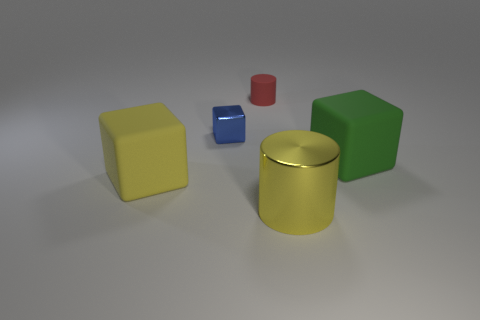How big is the cylinder that is behind the shiny block?
Offer a very short reply. Small. What size is the other object that is the same material as the blue thing?
Make the answer very short. Large. What number of matte things are the same color as the large metal cylinder?
Make the answer very short. 1. Is there a small red cylinder?
Your answer should be very brief. Yes. There is a big green rubber object; is it the same shape as the big yellow thing on the left side of the red cylinder?
Ensure brevity in your answer.  Yes. There is a small thing that is behind the metallic thing behind the big matte cube that is on the right side of the small rubber thing; what is its color?
Give a very brief answer. Red. Are there any shiny things left of the green cube?
Your response must be concise. Yes. Are there any big things made of the same material as the tiny cube?
Keep it short and to the point. Yes. What is the color of the metallic cylinder?
Make the answer very short. Yellow. Is the shape of the large thing that is in front of the yellow matte block the same as  the tiny matte thing?
Keep it short and to the point. Yes. 